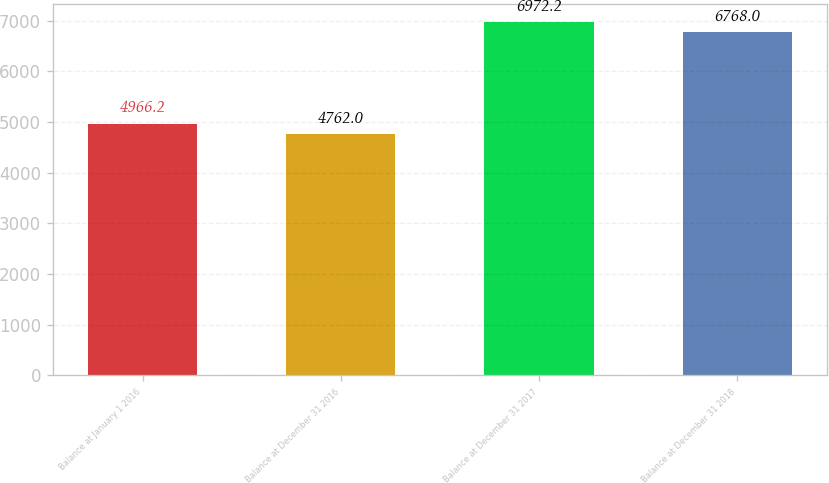Convert chart to OTSL. <chart><loc_0><loc_0><loc_500><loc_500><bar_chart><fcel>Balance at January 1 2016<fcel>Balance at December 31 2016<fcel>Balance at December 31 2017<fcel>Balance at December 31 2018<nl><fcel>4966.2<fcel>4762<fcel>6972.2<fcel>6768<nl></chart> 